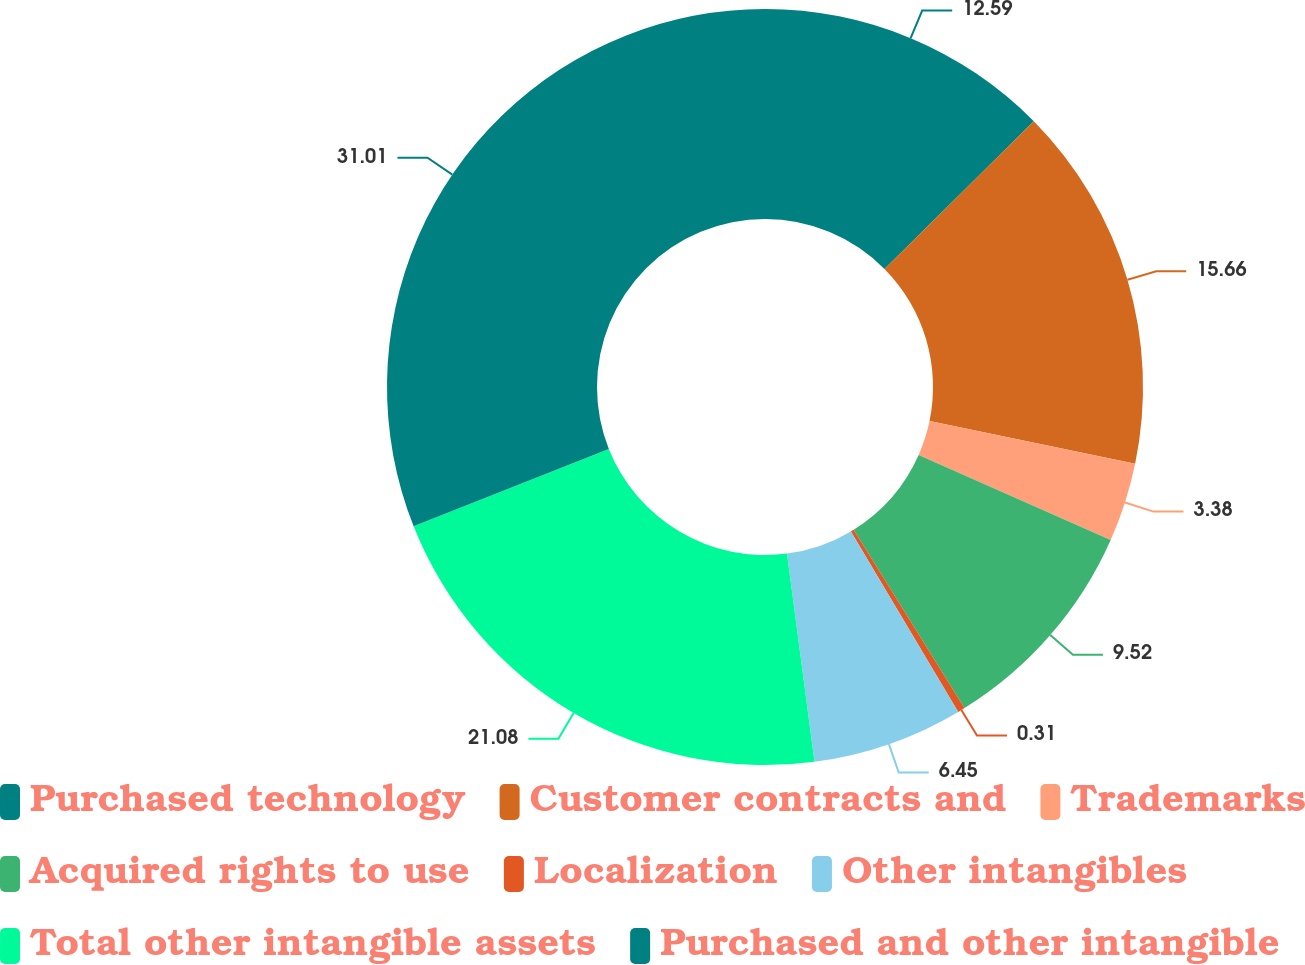Convert chart to OTSL. <chart><loc_0><loc_0><loc_500><loc_500><pie_chart><fcel>Purchased technology<fcel>Customer contracts and<fcel>Trademarks<fcel>Acquired rights to use<fcel>Localization<fcel>Other intangibles<fcel>Total other intangible assets<fcel>Purchased and other intangible<nl><fcel>12.59%<fcel>15.66%<fcel>3.38%<fcel>9.52%<fcel>0.31%<fcel>6.45%<fcel>21.08%<fcel>31.01%<nl></chart> 